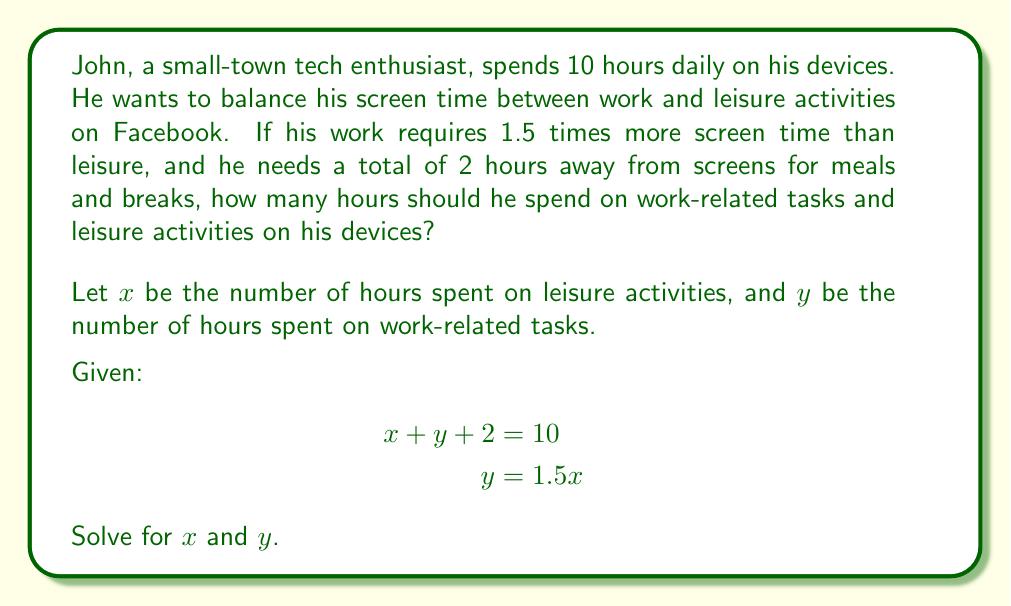Provide a solution to this math problem. Let's solve this system of equations step by step:

1) We have two equations:
   $$x + y + 2 = 10$$ (Equation 1)
   $$y = 1.5x$$ (Equation 2)

2) Substitute Equation 2 into Equation 1:
   $$x + 1.5x + 2 = 10$$

3) Simplify:
   $$2.5x + 2 = 10$$

4) Subtract 2 from both sides:
   $$2.5x = 8$$

5) Divide both sides by 2.5:
   $$x = 3.2$$

6) Now that we know $x$, we can find $y$ using Equation 2:
   $$y = 1.5(3.2) = 4.8$$

7) Let's verify our solution:
   $$x + y + 2 = 3.2 + 4.8 + 2 = 10$$

Therefore, John should spend 3.2 hours on leisure activities (mainly on Facebook) and 4.8 hours on work-related tasks.
Answer: Leisure activities (x): 3.2 hours
Work-related tasks (y): 4.8 hours 